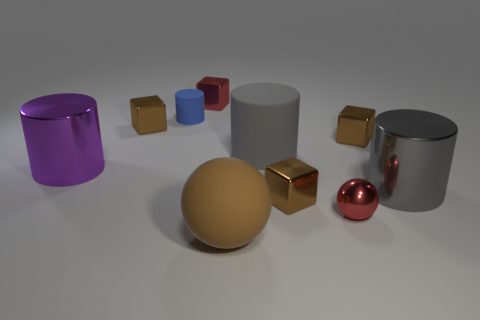There is a small metallic thing that is the same color as the tiny shiny sphere; what is its shape?
Make the answer very short. Cube. Does the small red object that is behind the tiny cylinder have the same shape as the brown object on the left side of the small rubber thing?
Offer a very short reply. Yes. There is a big purple thing that is the same shape as the small blue rubber object; what material is it?
Provide a short and direct response. Metal. The metallic object that is in front of the gray rubber cylinder and to the left of the large rubber ball is what color?
Your answer should be very brief. Purple. There is a tiny red metallic object in front of the small red object that is on the left side of the big brown rubber sphere; are there any big metallic objects in front of it?
Give a very brief answer. No. What number of things are either metal blocks or large purple metal spheres?
Provide a short and direct response. 4. Are the large brown object and the blue object to the left of the large matte sphere made of the same material?
Offer a very short reply. Yes. Is there anything else of the same color as the tiny rubber thing?
Provide a succinct answer. No. How many objects are either metal objects right of the large brown thing or tiny shiny things that are behind the small red metal sphere?
Offer a terse response. 6. What shape is the brown thing that is on the left side of the gray matte cylinder and behind the large ball?
Your answer should be compact. Cube. 